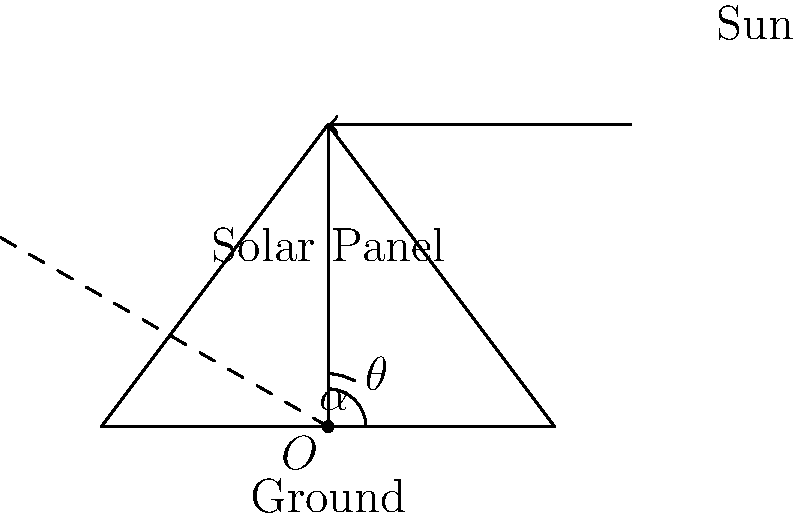In sustainable infrastructure design, the angle of solar panels is crucial for maximizing energy capture. Consider a solar panel installation where the sun's elevation angle ($\alpha$) is 60°. What should be the optimal tilt angle ($\theta$) of the solar panel with respect to the ground to ensure maximum energy capture? To determine the optimal tilt angle of the solar panel, we need to follow these steps:

1) The principle for maximum energy capture is that the solar panel should be perpendicular to the incoming sunlight.

2) In the diagram, we can see that:
   - $\alpha$ represents the sun's elevation angle from the horizontal.
   - $\theta$ represents the tilt angle of the solar panel from the horizontal.

3) For the panel to be perpendicular to the sunlight, the angle between the panel and the sun's rays should be 90°.

4) We can express this relationship mathematically:
   $\alpha + \theta + 90° = 180°$

5) Rearranging the equation:
   $\theta = 180° - 90° - \alpha$
   $\theta = 90° - \alpha$

6) Given that $\alpha = 60°$, we can calculate $\theta$:
   $\theta = 90° - 60° = 30°$

Therefore, the optimal tilt angle of the solar panel should be 30° from the horizontal.
Answer: 30° 